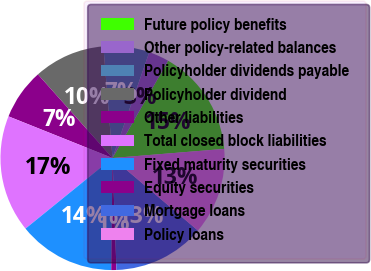Convert chart. <chart><loc_0><loc_0><loc_500><loc_500><pie_chart><fcel>Future policy benefits<fcel>Other policy-related balances<fcel>Policyholder dividends payable<fcel>Policyholder dividend<fcel>Other liabilities<fcel>Total closed block liabilities<fcel>Fixed maturity securities<fcel>Equity securities<fcel>Mortgage loans<fcel>Policy loans<nl><fcel>15.44%<fcel>2.94%<fcel>6.62%<fcel>10.29%<fcel>7.35%<fcel>16.91%<fcel>13.97%<fcel>0.74%<fcel>13.23%<fcel>12.5%<nl></chart> 